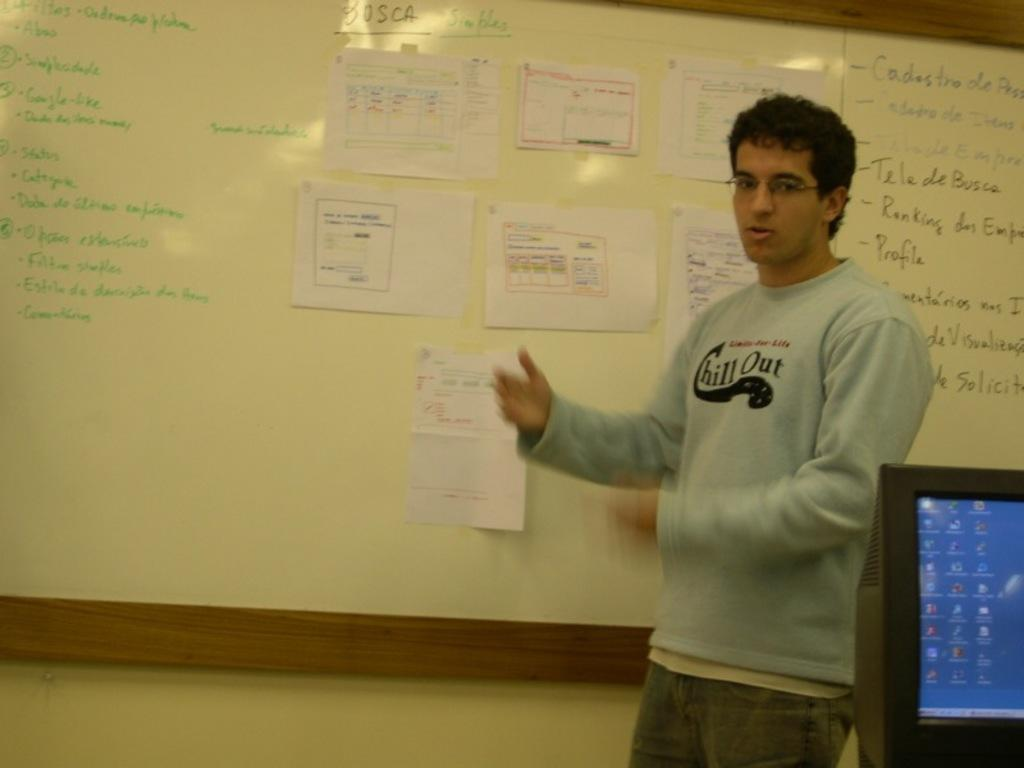<image>
Summarize the visual content of the image. A man wears a sweatshirt with the words chill out on it as he stands in front of a white board. 